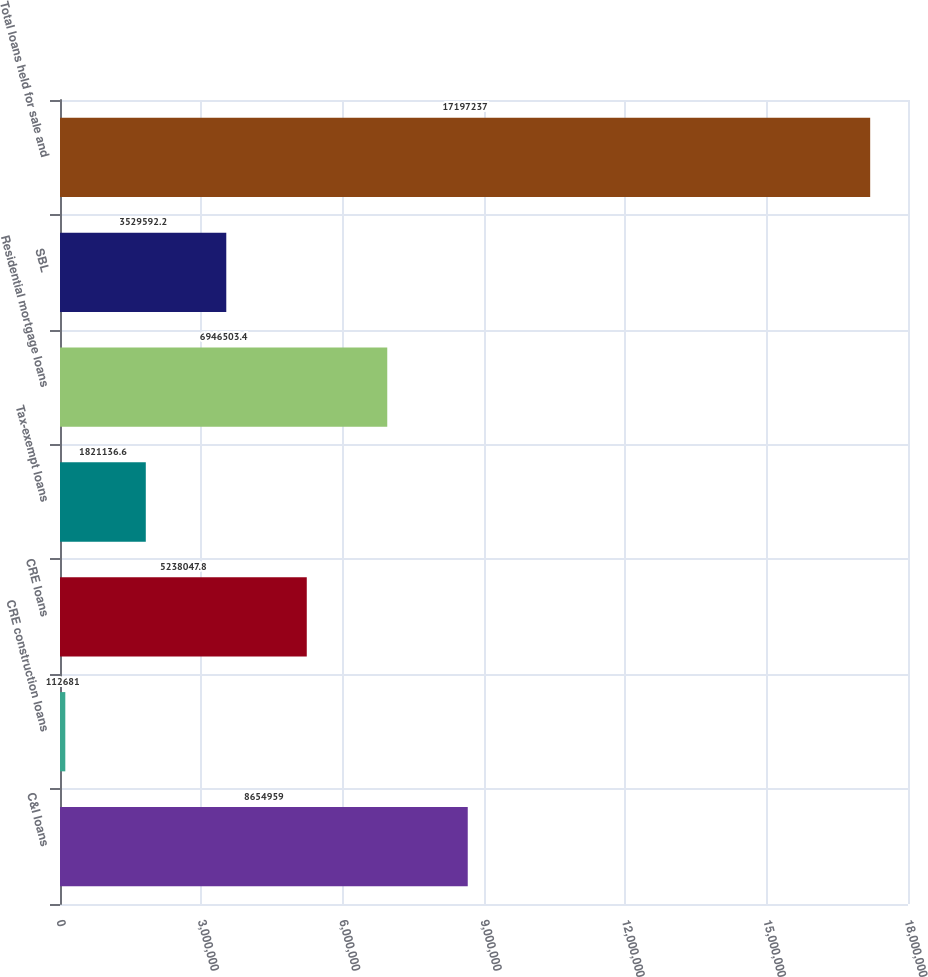<chart> <loc_0><loc_0><loc_500><loc_500><bar_chart><fcel>C&I loans<fcel>CRE construction loans<fcel>CRE loans<fcel>Tax-exempt loans<fcel>Residential mortgage loans<fcel>SBL<fcel>Total loans held for sale and<nl><fcel>8.65496e+06<fcel>112681<fcel>5.23805e+06<fcel>1.82114e+06<fcel>6.9465e+06<fcel>3.52959e+06<fcel>1.71972e+07<nl></chart> 